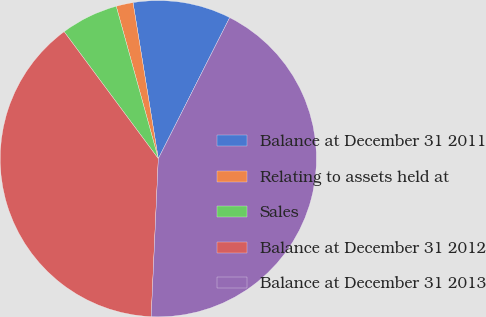<chart> <loc_0><loc_0><loc_500><loc_500><pie_chart><fcel>Balance at December 31 2011<fcel>Relating to assets held at<fcel>Sales<fcel>Balance at December 31 2012<fcel>Balance at December 31 2013<nl><fcel>10.01%<fcel>1.73%<fcel>5.87%<fcel>39.13%<fcel>43.27%<nl></chart> 